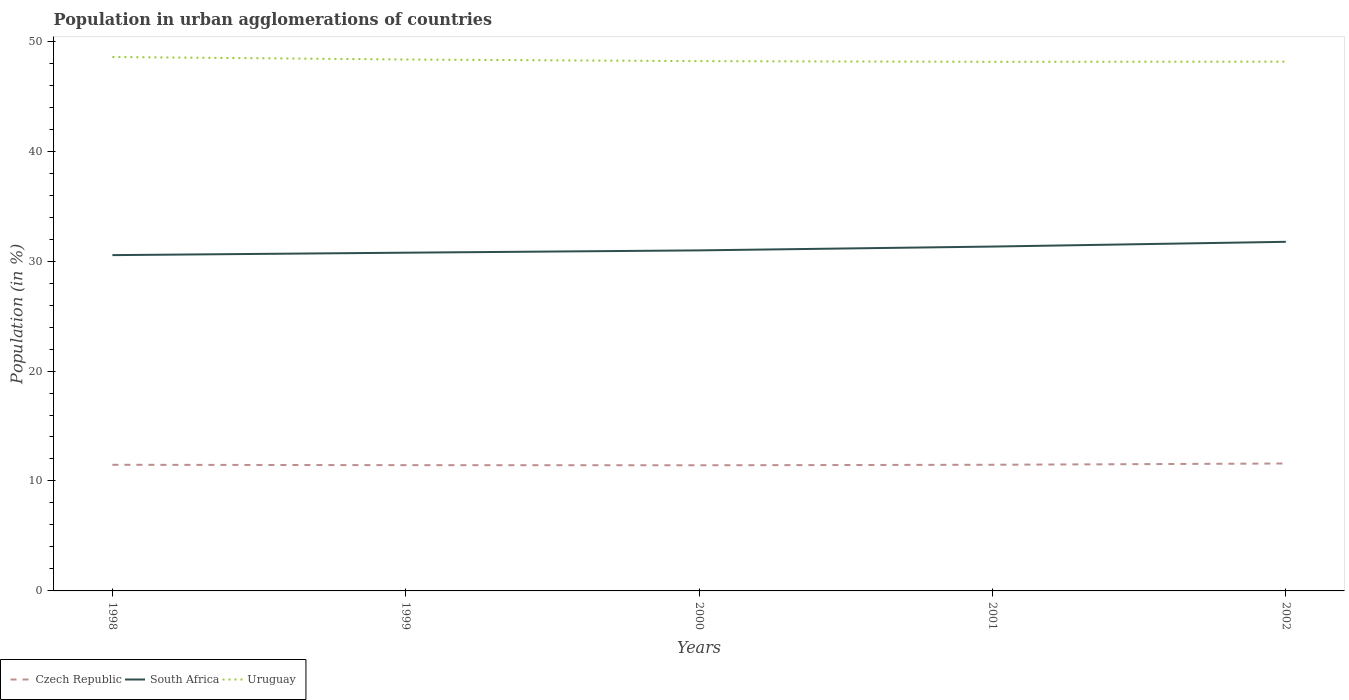Does the line corresponding to South Africa intersect with the line corresponding to Uruguay?
Your answer should be compact. No. Is the number of lines equal to the number of legend labels?
Offer a terse response. Yes. Across all years, what is the maximum percentage of population in urban agglomerations in Czech Republic?
Provide a short and direct response. 11.43. What is the total percentage of population in urban agglomerations in Czech Republic in the graph?
Offer a terse response. 0.04. What is the difference between the highest and the second highest percentage of population in urban agglomerations in South Africa?
Offer a very short reply. 1.21. What is the difference between the highest and the lowest percentage of population in urban agglomerations in Uruguay?
Give a very brief answer. 2. Is the percentage of population in urban agglomerations in Czech Republic strictly greater than the percentage of population in urban agglomerations in South Africa over the years?
Your answer should be very brief. Yes. How many years are there in the graph?
Your response must be concise. 5. What is the difference between two consecutive major ticks on the Y-axis?
Offer a very short reply. 10. Where does the legend appear in the graph?
Your response must be concise. Bottom left. What is the title of the graph?
Give a very brief answer. Population in urban agglomerations of countries. What is the Population (in %) in Czech Republic in 1998?
Provide a short and direct response. 11.47. What is the Population (in %) of South Africa in 1998?
Make the answer very short. 30.54. What is the Population (in %) in Uruguay in 1998?
Offer a terse response. 48.56. What is the Population (in %) of Czech Republic in 1999?
Give a very brief answer. 11.44. What is the Population (in %) of South Africa in 1999?
Offer a terse response. 30.76. What is the Population (in %) in Uruguay in 1999?
Offer a very short reply. 48.34. What is the Population (in %) of Czech Republic in 2000?
Make the answer very short. 11.43. What is the Population (in %) in South Africa in 2000?
Your response must be concise. 30.97. What is the Population (in %) of Uruguay in 2000?
Offer a terse response. 48.19. What is the Population (in %) of Czech Republic in 2001?
Provide a short and direct response. 11.47. What is the Population (in %) in South Africa in 2001?
Keep it short and to the point. 31.32. What is the Population (in %) of Uruguay in 2001?
Your response must be concise. 48.13. What is the Population (in %) of Czech Republic in 2002?
Offer a very short reply. 11.59. What is the Population (in %) of South Africa in 2002?
Ensure brevity in your answer.  31.75. What is the Population (in %) of Uruguay in 2002?
Your answer should be very brief. 48.14. Across all years, what is the maximum Population (in %) of Czech Republic?
Give a very brief answer. 11.59. Across all years, what is the maximum Population (in %) in South Africa?
Provide a succinct answer. 31.75. Across all years, what is the maximum Population (in %) of Uruguay?
Keep it short and to the point. 48.56. Across all years, what is the minimum Population (in %) in Czech Republic?
Provide a short and direct response. 11.43. Across all years, what is the minimum Population (in %) of South Africa?
Make the answer very short. 30.54. Across all years, what is the minimum Population (in %) of Uruguay?
Give a very brief answer. 48.13. What is the total Population (in %) in Czech Republic in the graph?
Offer a terse response. 57.41. What is the total Population (in %) of South Africa in the graph?
Keep it short and to the point. 155.36. What is the total Population (in %) of Uruguay in the graph?
Your answer should be very brief. 241.35. What is the difference between the Population (in %) in Czech Republic in 1998 and that in 1999?
Provide a short and direct response. 0.03. What is the difference between the Population (in %) of South Africa in 1998 and that in 1999?
Give a very brief answer. -0.22. What is the difference between the Population (in %) of Uruguay in 1998 and that in 1999?
Offer a very short reply. 0.23. What is the difference between the Population (in %) in Czech Republic in 1998 and that in 2000?
Keep it short and to the point. 0.04. What is the difference between the Population (in %) in South Africa in 1998 and that in 2000?
Provide a short and direct response. -0.43. What is the difference between the Population (in %) in Uruguay in 1998 and that in 2000?
Provide a short and direct response. 0.38. What is the difference between the Population (in %) in Czech Republic in 1998 and that in 2001?
Your answer should be compact. -0. What is the difference between the Population (in %) of South Africa in 1998 and that in 2001?
Keep it short and to the point. -0.78. What is the difference between the Population (in %) of Uruguay in 1998 and that in 2001?
Give a very brief answer. 0.44. What is the difference between the Population (in %) in Czech Republic in 1998 and that in 2002?
Your response must be concise. -0.12. What is the difference between the Population (in %) of South Africa in 1998 and that in 2002?
Offer a very short reply. -1.21. What is the difference between the Population (in %) of Uruguay in 1998 and that in 2002?
Make the answer very short. 0.42. What is the difference between the Population (in %) in Czech Republic in 1999 and that in 2000?
Your answer should be very brief. 0.01. What is the difference between the Population (in %) in South Africa in 1999 and that in 2000?
Your answer should be compact. -0.21. What is the difference between the Population (in %) of Uruguay in 1999 and that in 2000?
Ensure brevity in your answer.  0.15. What is the difference between the Population (in %) of Czech Republic in 1999 and that in 2001?
Offer a terse response. -0.03. What is the difference between the Population (in %) in South Africa in 1999 and that in 2001?
Ensure brevity in your answer.  -0.56. What is the difference between the Population (in %) in Uruguay in 1999 and that in 2001?
Offer a terse response. 0.21. What is the difference between the Population (in %) of South Africa in 1999 and that in 2002?
Your response must be concise. -0.99. What is the difference between the Population (in %) of Uruguay in 1999 and that in 2002?
Ensure brevity in your answer.  0.2. What is the difference between the Population (in %) in Czech Republic in 2000 and that in 2001?
Ensure brevity in your answer.  -0.05. What is the difference between the Population (in %) in South Africa in 2000 and that in 2001?
Your answer should be compact. -0.35. What is the difference between the Population (in %) of Uruguay in 2000 and that in 2001?
Provide a short and direct response. 0.06. What is the difference between the Population (in %) of Czech Republic in 2000 and that in 2002?
Offer a very short reply. -0.16. What is the difference between the Population (in %) in South Africa in 2000 and that in 2002?
Your answer should be compact. -0.78. What is the difference between the Population (in %) of Uruguay in 2000 and that in 2002?
Offer a very short reply. 0.05. What is the difference between the Population (in %) in Czech Republic in 2001 and that in 2002?
Your response must be concise. -0.12. What is the difference between the Population (in %) in South Africa in 2001 and that in 2002?
Your answer should be compact. -0.43. What is the difference between the Population (in %) in Uruguay in 2001 and that in 2002?
Your answer should be compact. -0.01. What is the difference between the Population (in %) in Czech Republic in 1998 and the Population (in %) in South Africa in 1999?
Make the answer very short. -19.29. What is the difference between the Population (in %) of Czech Republic in 1998 and the Population (in %) of Uruguay in 1999?
Keep it short and to the point. -36.86. What is the difference between the Population (in %) of South Africa in 1998 and the Population (in %) of Uruguay in 1999?
Provide a short and direct response. -17.79. What is the difference between the Population (in %) in Czech Republic in 1998 and the Population (in %) in South Africa in 2000?
Offer a very short reply. -19.5. What is the difference between the Population (in %) of Czech Republic in 1998 and the Population (in %) of Uruguay in 2000?
Provide a short and direct response. -36.71. What is the difference between the Population (in %) in South Africa in 1998 and the Population (in %) in Uruguay in 2000?
Keep it short and to the point. -17.64. What is the difference between the Population (in %) of Czech Republic in 1998 and the Population (in %) of South Africa in 2001?
Ensure brevity in your answer.  -19.85. What is the difference between the Population (in %) in Czech Republic in 1998 and the Population (in %) in Uruguay in 2001?
Provide a succinct answer. -36.65. What is the difference between the Population (in %) in South Africa in 1998 and the Population (in %) in Uruguay in 2001?
Ensure brevity in your answer.  -17.58. What is the difference between the Population (in %) of Czech Republic in 1998 and the Population (in %) of South Africa in 2002?
Give a very brief answer. -20.28. What is the difference between the Population (in %) of Czech Republic in 1998 and the Population (in %) of Uruguay in 2002?
Offer a very short reply. -36.67. What is the difference between the Population (in %) in South Africa in 1998 and the Population (in %) in Uruguay in 2002?
Ensure brevity in your answer.  -17.6. What is the difference between the Population (in %) of Czech Republic in 1999 and the Population (in %) of South Africa in 2000?
Keep it short and to the point. -19.53. What is the difference between the Population (in %) in Czech Republic in 1999 and the Population (in %) in Uruguay in 2000?
Make the answer very short. -36.75. What is the difference between the Population (in %) of South Africa in 1999 and the Population (in %) of Uruguay in 2000?
Make the answer very short. -17.42. What is the difference between the Population (in %) of Czech Republic in 1999 and the Population (in %) of South Africa in 2001?
Make the answer very short. -19.88. What is the difference between the Population (in %) of Czech Republic in 1999 and the Population (in %) of Uruguay in 2001?
Your response must be concise. -36.69. What is the difference between the Population (in %) of South Africa in 1999 and the Population (in %) of Uruguay in 2001?
Provide a succinct answer. -17.36. What is the difference between the Population (in %) of Czech Republic in 1999 and the Population (in %) of South Africa in 2002?
Keep it short and to the point. -20.31. What is the difference between the Population (in %) of Czech Republic in 1999 and the Population (in %) of Uruguay in 2002?
Your answer should be very brief. -36.7. What is the difference between the Population (in %) of South Africa in 1999 and the Population (in %) of Uruguay in 2002?
Make the answer very short. -17.38. What is the difference between the Population (in %) of Czech Republic in 2000 and the Population (in %) of South Africa in 2001?
Make the answer very short. -19.89. What is the difference between the Population (in %) in Czech Republic in 2000 and the Population (in %) in Uruguay in 2001?
Keep it short and to the point. -36.7. What is the difference between the Population (in %) of South Africa in 2000 and the Population (in %) of Uruguay in 2001?
Offer a terse response. -17.15. What is the difference between the Population (in %) of Czech Republic in 2000 and the Population (in %) of South Africa in 2002?
Keep it short and to the point. -20.32. What is the difference between the Population (in %) of Czech Republic in 2000 and the Population (in %) of Uruguay in 2002?
Your answer should be very brief. -36.71. What is the difference between the Population (in %) of South Africa in 2000 and the Population (in %) of Uruguay in 2002?
Keep it short and to the point. -17.17. What is the difference between the Population (in %) of Czech Republic in 2001 and the Population (in %) of South Africa in 2002?
Keep it short and to the point. -20.28. What is the difference between the Population (in %) in Czech Republic in 2001 and the Population (in %) in Uruguay in 2002?
Make the answer very short. -36.67. What is the difference between the Population (in %) of South Africa in 2001 and the Population (in %) of Uruguay in 2002?
Give a very brief answer. -16.82. What is the average Population (in %) of Czech Republic per year?
Provide a succinct answer. 11.48. What is the average Population (in %) in South Africa per year?
Offer a very short reply. 31.07. What is the average Population (in %) of Uruguay per year?
Your answer should be compact. 48.27. In the year 1998, what is the difference between the Population (in %) in Czech Republic and Population (in %) in South Africa?
Your response must be concise. -19.07. In the year 1998, what is the difference between the Population (in %) of Czech Republic and Population (in %) of Uruguay?
Make the answer very short. -37.09. In the year 1998, what is the difference between the Population (in %) in South Africa and Population (in %) in Uruguay?
Make the answer very short. -18.02. In the year 1999, what is the difference between the Population (in %) in Czech Republic and Population (in %) in South Africa?
Offer a very short reply. -19.32. In the year 1999, what is the difference between the Population (in %) in Czech Republic and Population (in %) in Uruguay?
Offer a terse response. -36.9. In the year 1999, what is the difference between the Population (in %) of South Africa and Population (in %) of Uruguay?
Offer a very short reply. -17.57. In the year 2000, what is the difference between the Population (in %) of Czech Republic and Population (in %) of South Africa?
Your response must be concise. -19.55. In the year 2000, what is the difference between the Population (in %) in Czech Republic and Population (in %) in Uruguay?
Keep it short and to the point. -36.76. In the year 2000, what is the difference between the Population (in %) of South Africa and Population (in %) of Uruguay?
Keep it short and to the point. -17.21. In the year 2001, what is the difference between the Population (in %) in Czech Republic and Population (in %) in South Africa?
Provide a short and direct response. -19.85. In the year 2001, what is the difference between the Population (in %) in Czech Republic and Population (in %) in Uruguay?
Offer a very short reply. -36.65. In the year 2001, what is the difference between the Population (in %) in South Africa and Population (in %) in Uruguay?
Your answer should be compact. -16.81. In the year 2002, what is the difference between the Population (in %) of Czech Republic and Population (in %) of South Africa?
Offer a terse response. -20.16. In the year 2002, what is the difference between the Population (in %) of Czech Republic and Population (in %) of Uruguay?
Give a very brief answer. -36.55. In the year 2002, what is the difference between the Population (in %) in South Africa and Population (in %) in Uruguay?
Ensure brevity in your answer.  -16.39. What is the ratio of the Population (in %) of Czech Republic in 1998 to that in 1999?
Offer a terse response. 1. What is the ratio of the Population (in %) of Uruguay in 1998 to that in 1999?
Your answer should be compact. 1. What is the ratio of the Population (in %) of Czech Republic in 1998 to that in 2000?
Offer a terse response. 1. What is the ratio of the Population (in %) in South Africa in 1998 to that in 2001?
Offer a terse response. 0.98. What is the ratio of the Population (in %) of Uruguay in 1998 to that in 2001?
Provide a short and direct response. 1.01. What is the ratio of the Population (in %) of Czech Republic in 1998 to that in 2002?
Provide a succinct answer. 0.99. What is the ratio of the Population (in %) of South Africa in 1998 to that in 2002?
Offer a terse response. 0.96. What is the ratio of the Population (in %) of Uruguay in 1998 to that in 2002?
Your answer should be compact. 1.01. What is the ratio of the Population (in %) in Czech Republic in 1999 to that in 2000?
Keep it short and to the point. 1. What is the ratio of the Population (in %) in South Africa in 1999 to that in 2000?
Your answer should be compact. 0.99. What is the ratio of the Population (in %) in South Africa in 1999 to that in 2001?
Your response must be concise. 0.98. What is the ratio of the Population (in %) in Uruguay in 1999 to that in 2001?
Provide a succinct answer. 1. What is the ratio of the Population (in %) in Czech Republic in 1999 to that in 2002?
Offer a very short reply. 0.99. What is the ratio of the Population (in %) in South Africa in 1999 to that in 2002?
Offer a very short reply. 0.97. What is the ratio of the Population (in %) in South Africa in 2000 to that in 2001?
Ensure brevity in your answer.  0.99. What is the ratio of the Population (in %) of Czech Republic in 2000 to that in 2002?
Offer a very short reply. 0.99. What is the ratio of the Population (in %) of South Africa in 2000 to that in 2002?
Your answer should be very brief. 0.98. What is the ratio of the Population (in %) of Uruguay in 2000 to that in 2002?
Keep it short and to the point. 1. What is the ratio of the Population (in %) in Czech Republic in 2001 to that in 2002?
Offer a terse response. 0.99. What is the ratio of the Population (in %) in South Africa in 2001 to that in 2002?
Ensure brevity in your answer.  0.99. What is the difference between the highest and the second highest Population (in %) of Czech Republic?
Your response must be concise. 0.12. What is the difference between the highest and the second highest Population (in %) in South Africa?
Give a very brief answer. 0.43. What is the difference between the highest and the second highest Population (in %) of Uruguay?
Offer a very short reply. 0.23. What is the difference between the highest and the lowest Population (in %) of Czech Republic?
Make the answer very short. 0.16. What is the difference between the highest and the lowest Population (in %) of South Africa?
Ensure brevity in your answer.  1.21. What is the difference between the highest and the lowest Population (in %) in Uruguay?
Make the answer very short. 0.44. 